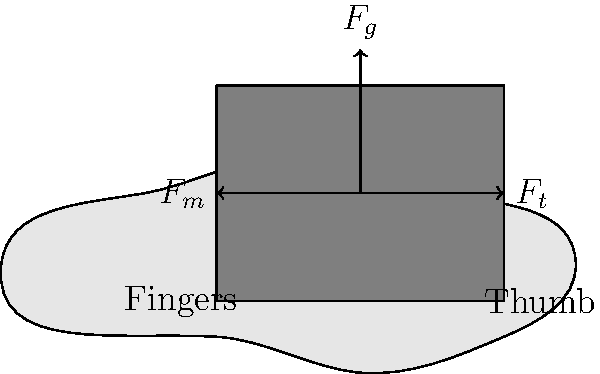When holding a large format camera, the stability of the hand is crucial for capturing sharp images. Consider the forces acting on the camera when held steady. If the weight of the camera ($F_g$) is 2.5 N, what should be the minimum combined muscular force ($F_m + F_t$) exerted by the fingers and thumb to maintain equilibrium? To solve this problem, we need to consider the equilibrium of forces acting on the camera:

1. The weight of the camera ($F_g$) acts downward.
2. The muscular force from the fingers ($F_m$) acts to the left.
3. The muscular force from the thumb ($F_t$) acts to the right.

For the camera to be in equilibrium:

1. The sum of vertical forces must be zero:
   $$F_g - F_n = 0$$
   where $F_n$ is the normal force from the hand.

2. The sum of horizontal forces must be zero:
   $$F_m - F_t = 0$$

3. The total muscular force ($F_m + F_t$) must be equal to or greater than the weight of the camera to prevent slipping:
   $$F_m + F_t \geq F_g$$

Given that $F_g = 2.5$ N, the minimum combined muscular force to maintain equilibrium is:

$$F_m + F_t = F_g = 2.5 \text{ N}$$

This ensures that the camera doesn't slip out of the hand while also maintaining horizontal equilibrium.
Answer: 2.5 N 